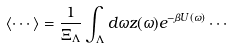<formula> <loc_0><loc_0><loc_500><loc_500>\langle \cdots \rangle = \frac { 1 } { \Xi _ { \Lambda } } \int _ { \Lambda } d \omega z ( \omega ) e ^ { - \beta U ( \omega ) } \cdots</formula> 